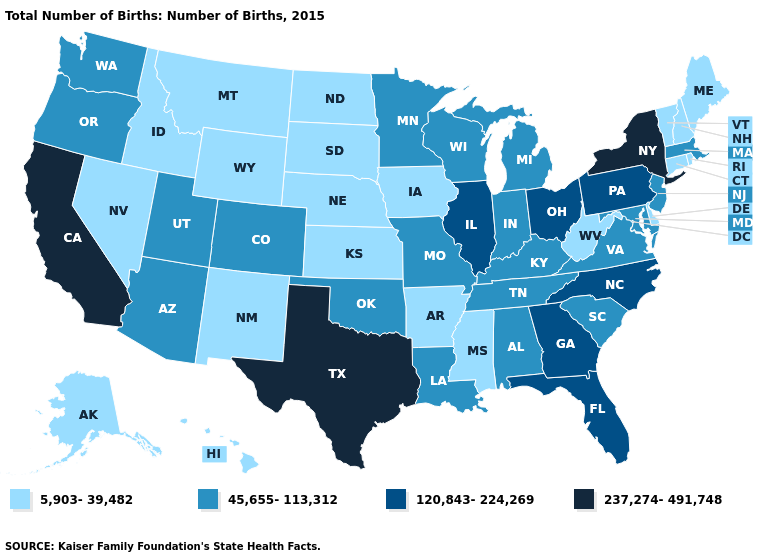Does the map have missing data?
Concise answer only. No. What is the value of Oklahoma?
Write a very short answer. 45,655-113,312. What is the highest value in the South ?
Be succinct. 237,274-491,748. What is the lowest value in the USA?
Keep it brief. 5,903-39,482. Among the states that border South Dakota , does Minnesota have the lowest value?
Answer briefly. No. How many symbols are there in the legend?
Short answer required. 4. Name the states that have a value in the range 237,274-491,748?
Write a very short answer. California, New York, Texas. Among the states that border Colorado , which have the lowest value?
Give a very brief answer. Kansas, Nebraska, New Mexico, Wyoming. Which states have the lowest value in the MidWest?
Write a very short answer. Iowa, Kansas, Nebraska, North Dakota, South Dakota. What is the value of Delaware?
Write a very short answer. 5,903-39,482. What is the lowest value in the USA?
Quick response, please. 5,903-39,482. Name the states that have a value in the range 237,274-491,748?
Quick response, please. California, New York, Texas. What is the highest value in the MidWest ?
Concise answer only. 120,843-224,269. What is the value of Alaska?
Keep it brief. 5,903-39,482. Does California have the highest value in the USA?
Short answer required. Yes. 